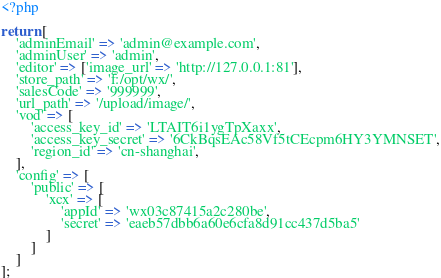Convert code to text. <code><loc_0><loc_0><loc_500><loc_500><_PHP_><?php

return [
    'adminEmail' => 'admin@example.com',
    'adminUser' => 'admin',
    'editor' => ['image_url' => 'http://127.0.0.1:81'],
    'store_path' => 'f:/opt/wx/',
    'salesCode' => '999999',
    'url_path' => '/upload/image/',
    'vod' => [
        'access_key_id' => 'LTAIT6i1ygTpXaxx',
        'access_key_secret' => '6CkBqsEAc58Vf5tCEcpm6HY3YMNSET',
        'region_id' => 'cn-shanghai',
    ],
    'config' => [
        'public' => [
            'xcx' => [
                'appId' => 'wx03c87415a2c280be',
                'secret' => 'eaeb57dbb6a60e6cfa8d91cc437d5ba5'
            ]
        ]
    ]
];</code> 